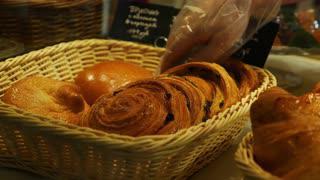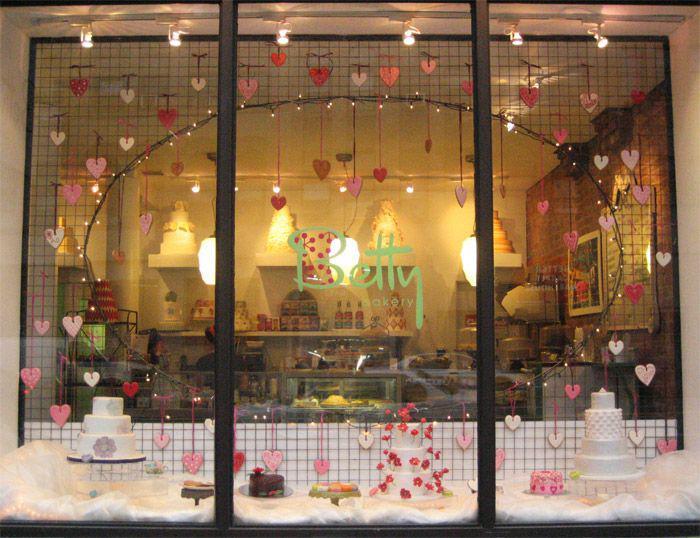The first image is the image on the left, the second image is the image on the right. Analyze the images presented: Is the assertion "Two bakery windows show the reflection of at least one person." valid? Answer yes or no. No. The first image is the image on the left, the second image is the image on the right. Considering the images on both sides, is "The left image shows tiered shelves of baked goods behind glass, with white cards above some items facing the glass." valid? Answer yes or no. No. 